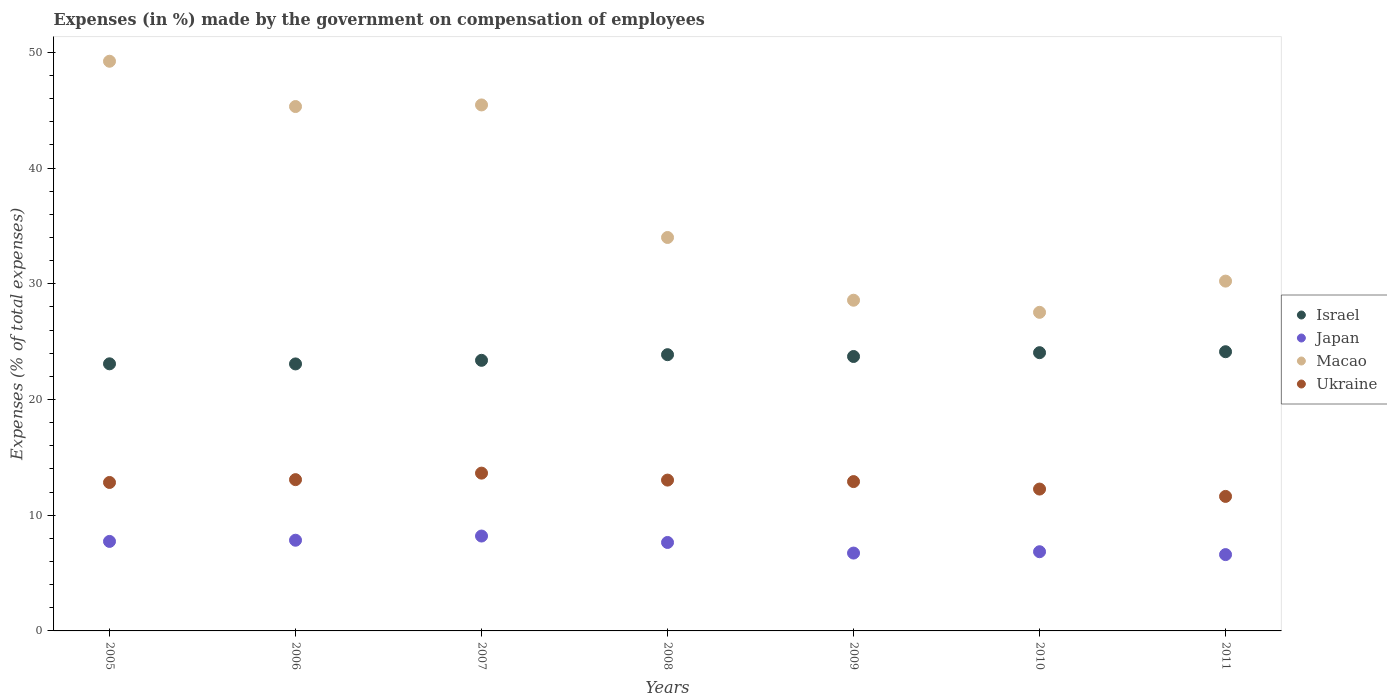How many different coloured dotlines are there?
Your answer should be very brief. 4. Is the number of dotlines equal to the number of legend labels?
Provide a short and direct response. Yes. What is the percentage of expenses made by the government on compensation of employees in Japan in 2006?
Make the answer very short. 7.84. Across all years, what is the maximum percentage of expenses made by the government on compensation of employees in Japan?
Provide a succinct answer. 8.2. Across all years, what is the minimum percentage of expenses made by the government on compensation of employees in Japan?
Your answer should be very brief. 6.6. In which year was the percentage of expenses made by the government on compensation of employees in Japan maximum?
Keep it short and to the point. 2007. In which year was the percentage of expenses made by the government on compensation of employees in Japan minimum?
Your answer should be compact. 2011. What is the total percentage of expenses made by the government on compensation of employees in Macao in the graph?
Offer a very short reply. 260.37. What is the difference between the percentage of expenses made by the government on compensation of employees in Macao in 2005 and that in 2009?
Make the answer very short. 20.65. What is the difference between the percentage of expenses made by the government on compensation of employees in Japan in 2011 and the percentage of expenses made by the government on compensation of employees in Israel in 2009?
Provide a short and direct response. -17.12. What is the average percentage of expenses made by the government on compensation of employees in Japan per year?
Your response must be concise. 7.37. In the year 2006, what is the difference between the percentage of expenses made by the government on compensation of employees in Japan and percentage of expenses made by the government on compensation of employees in Macao?
Give a very brief answer. -37.48. What is the ratio of the percentage of expenses made by the government on compensation of employees in Israel in 2006 to that in 2009?
Give a very brief answer. 0.97. What is the difference between the highest and the second highest percentage of expenses made by the government on compensation of employees in Ukraine?
Ensure brevity in your answer.  0.56. What is the difference between the highest and the lowest percentage of expenses made by the government on compensation of employees in Japan?
Provide a short and direct response. 1.6. In how many years, is the percentage of expenses made by the government on compensation of employees in Macao greater than the average percentage of expenses made by the government on compensation of employees in Macao taken over all years?
Provide a short and direct response. 3. Is the sum of the percentage of expenses made by the government on compensation of employees in Macao in 2005 and 2006 greater than the maximum percentage of expenses made by the government on compensation of employees in Japan across all years?
Ensure brevity in your answer.  Yes. Is it the case that in every year, the sum of the percentage of expenses made by the government on compensation of employees in Israel and percentage of expenses made by the government on compensation of employees in Japan  is greater than the sum of percentage of expenses made by the government on compensation of employees in Ukraine and percentage of expenses made by the government on compensation of employees in Macao?
Offer a terse response. No. Does the percentage of expenses made by the government on compensation of employees in Japan monotonically increase over the years?
Offer a terse response. No. Is the percentage of expenses made by the government on compensation of employees in Japan strictly greater than the percentage of expenses made by the government on compensation of employees in Ukraine over the years?
Offer a very short reply. No. Is the percentage of expenses made by the government on compensation of employees in Macao strictly less than the percentage of expenses made by the government on compensation of employees in Japan over the years?
Make the answer very short. No. How many years are there in the graph?
Your response must be concise. 7. What is the difference between two consecutive major ticks on the Y-axis?
Offer a very short reply. 10. Where does the legend appear in the graph?
Ensure brevity in your answer.  Center right. How are the legend labels stacked?
Your answer should be compact. Vertical. What is the title of the graph?
Ensure brevity in your answer.  Expenses (in %) made by the government on compensation of employees. Does "Sao Tome and Principe" appear as one of the legend labels in the graph?
Provide a succinct answer. No. What is the label or title of the X-axis?
Provide a short and direct response. Years. What is the label or title of the Y-axis?
Offer a terse response. Expenses (% of total expenses). What is the Expenses (% of total expenses) of Israel in 2005?
Give a very brief answer. 23.09. What is the Expenses (% of total expenses) of Japan in 2005?
Offer a very short reply. 7.74. What is the Expenses (% of total expenses) of Macao in 2005?
Your answer should be compact. 49.24. What is the Expenses (% of total expenses) of Ukraine in 2005?
Offer a terse response. 12.83. What is the Expenses (% of total expenses) in Israel in 2006?
Offer a very short reply. 23.08. What is the Expenses (% of total expenses) in Japan in 2006?
Your answer should be compact. 7.84. What is the Expenses (% of total expenses) of Macao in 2006?
Your answer should be compact. 45.32. What is the Expenses (% of total expenses) of Ukraine in 2006?
Offer a terse response. 13.07. What is the Expenses (% of total expenses) of Israel in 2007?
Your answer should be very brief. 23.39. What is the Expenses (% of total expenses) in Japan in 2007?
Provide a short and direct response. 8.2. What is the Expenses (% of total expenses) in Macao in 2007?
Provide a short and direct response. 45.46. What is the Expenses (% of total expenses) in Ukraine in 2007?
Make the answer very short. 13.64. What is the Expenses (% of total expenses) in Israel in 2008?
Give a very brief answer. 23.87. What is the Expenses (% of total expenses) in Japan in 2008?
Offer a very short reply. 7.65. What is the Expenses (% of total expenses) of Macao in 2008?
Your response must be concise. 34. What is the Expenses (% of total expenses) in Ukraine in 2008?
Provide a short and direct response. 13.04. What is the Expenses (% of total expenses) in Israel in 2009?
Ensure brevity in your answer.  23.72. What is the Expenses (% of total expenses) in Japan in 2009?
Your answer should be very brief. 6.73. What is the Expenses (% of total expenses) in Macao in 2009?
Offer a very short reply. 28.58. What is the Expenses (% of total expenses) of Ukraine in 2009?
Offer a terse response. 12.91. What is the Expenses (% of total expenses) in Israel in 2010?
Your answer should be compact. 24.05. What is the Expenses (% of total expenses) of Japan in 2010?
Make the answer very short. 6.85. What is the Expenses (% of total expenses) in Macao in 2010?
Your answer should be very brief. 27.54. What is the Expenses (% of total expenses) of Ukraine in 2010?
Offer a terse response. 12.26. What is the Expenses (% of total expenses) of Israel in 2011?
Make the answer very short. 24.13. What is the Expenses (% of total expenses) in Japan in 2011?
Give a very brief answer. 6.6. What is the Expenses (% of total expenses) of Macao in 2011?
Your response must be concise. 30.23. What is the Expenses (% of total expenses) of Ukraine in 2011?
Offer a terse response. 11.63. Across all years, what is the maximum Expenses (% of total expenses) in Israel?
Give a very brief answer. 24.13. Across all years, what is the maximum Expenses (% of total expenses) of Japan?
Keep it short and to the point. 8.2. Across all years, what is the maximum Expenses (% of total expenses) in Macao?
Keep it short and to the point. 49.24. Across all years, what is the maximum Expenses (% of total expenses) of Ukraine?
Ensure brevity in your answer.  13.64. Across all years, what is the minimum Expenses (% of total expenses) of Israel?
Ensure brevity in your answer.  23.08. Across all years, what is the minimum Expenses (% of total expenses) of Japan?
Your answer should be very brief. 6.6. Across all years, what is the minimum Expenses (% of total expenses) of Macao?
Your response must be concise. 27.54. Across all years, what is the minimum Expenses (% of total expenses) of Ukraine?
Provide a succinct answer. 11.63. What is the total Expenses (% of total expenses) of Israel in the graph?
Offer a terse response. 165.32. What is the total Expenses (% of total expenses) in Japan in the graph?
Keep it short and to the point. 51.59. What is the total Expenses (% of total expenses) of Macao in the graph?
Provide a succinct answer. 260.37. What is the total Expenses (% of total expenses) in Ukraine in the graph?
Your response must be concise. 89.37. What is the difference between the Expenses (% of total expenses) in Israel in 2005 and that in 2006?
Ensure brevity in your answer.  0.01. What is the difference between the Expenses (% of total expenses) of Japan in 2005 and that in 2006?
Your answer should be compact. -0.1. What is the difference between the Expenses (% of total expenses) in Macao in 2005 and that in 2006?
Give a very brief answer. 3.91. What is the difference between the Expenses (% of total expenses) in Ukraine in 2005 and that in 2006?
Provide a short and direct response. -0.24. What is the difference between the Expenses (% of total expenses) in Israel in 2005 and that in 2007?
Provide a short and direct response. -0.3. What is the difference between the Expenses (% of total expenses) of Japan in 2005 and that in 2007?
Provide a succinct answer. -0.46. What is the difference between the Expenses (% of total expenses) of Macao in 2005 and that in 2007?
Provide a short and direct response. 3.78. What is the difference between the Expenses (% of total expenses) of Ukraine in 2005 and that in 2007?
Ensure brevity in your answer.  -0.81. What is the difference between the Expenses (% of total expenses) in Israel in 2005 and that in 2008?
Your answer should be compact. -0.79. What is the difference between the Expenses (% of total expenses) in Japan in 2005 and that in 2008?
Offer a very short reply. 0.09. What is the difference between the Expenses (% of total expenses) of Macao in 2005 and that in 2008?
Provide a short and direct response. 15.23. What is the difference between the Expenses (% of total expenses) of Ukraine in 2005 and that in 2008?
Provide a succinct answer. -0.2. What is the difference between the Expenses (% of total expenses) of Israel in 2005 and that in 2009?
Offer a very short reply. -0.63. What is the difference between the Expenses (% of total expenses) of Japan in 2005 and that in 2009?
Keep it short and to the point. 1.01. What is the difference between the Expenses (% of total expenses) in Macao in 2005 and that in 2009?
Ensure brevity in your answer.  20.65. What is the difference between the Expenses (% of total expenses) of Ukraine in 2005 and that in 2009?
Provide a succinct answer. -0.08. What is the difference between the Expenses (% of total expenses) in Israel in 2005 and that in 2010?
Your response must be concise. -0.96. What is the difference between the Expenses (% of total expenses) in Japan in 2005 and that in 2010?
Provide a succinct answer. 0.89. What is the difference between the Expenses (% of total expenses) of Macao in 2005 and that in 2010?
Offer a terse response. 21.7. What is the difference between the Expenses (% of total expenses) in Ukraine in 2005 and that in 2010?
Ensure brevity in your answer.  0.57. What is the difference between the Expenses (% of total expenses) in Israel in 2005 and that in 2011?
Your response must be concise. -1.05. What is the difference between the Expenses (% of total expenses) in Japan in 2005 and that in 2011?
Offer a terse response. 1.14. What is the difference between the Expenses (% of total expenses) of Macao in 2005 and that in 2011?
Offer a very short reply. 19. What is the difference between the Expenses (% of total expenses) of Ukraine in 2005 and that in 2011?
Make the answer very short. 1.21. What is the difference between the Expenses (% of total expenses) of Israel in 2006 and that in 2007?
Provide a short and direct response. -0.31. What is the difference between the Expenses (% of total expenses) in Japan in 2006 and that in 2007?
Provide a succinct answer. -0.36. What is the difference between the Expenses (% of total expenses) in Macao in 2006 and that in 2007?
Provide a short and direct response. -0.14. What is the difference between the Expenses (% of total expenses) in Ukraine in 2006 and that in 2007?
Offer a very short reply. -0.56. What is the difference between the Expenses (% of total expenses) of Israel in 2006 and that in 2008?
Your response must be concise. -0.8. What is the difference between the Expenses (% of total expenses) in Japan in 2006 and that in 2008?
Offer a very short reply. 0.19. What is the difference between the Expenses (% of total expenses) of Macao in 2006 and that in 2008?
Offer a terse response. 11.32. What is the difference between the Expenses (% of total expenses) in Ukraine in 2006 and that in 2008?
Your response must be concise. 0.04. What is the difference between the Expenses (% of total expenses) in Israel in 2006 and that in 2009?
Your response must be concise. -0.64. What is the difference between the Expenses (% of total expenses) in Japan in 2006 and that in 2009?
Offer a very short reply. 1.11. What is the difference between the Expenses (% of total expenses) of Macao in 2006 and that in 2009?
Keep it short and to the point. 16.74. What is the difference between the Expenses (% of total expenses) of Ukraine in 2006 and that in 2009?
Keep it short and to the point. 0.17. What is the difference between the Expenses (% of total expenses) of Israel in 2006 and that in 2010?
Offer a very short reply. -0.97. What is the difference between the Expenses (% of total expenses) in Japan in 2006 and that in 2010?
Your response must be concise. 0.99. What is the difference between the Expenses (% of total expenses) in Macao in 2006 and that in 2010?
Provide a succinct answer. 17.79. What is the difference between the Expenses (% of total expenses) in Ukraine in 2006 and that in 2010?
Provide a succinct answer. 0.81. What is the difference between the Expenses (% of total expenses) of Israel in 2006 and that in 2011?
Make the answer very short. -1.05. What is the difference between the Expenses (% of total expenses) of Japan in 2006 and that in 2011?
Make the answer very short. 1.24. What is the difference between the Expenses (% of total expenses) in Macao in 2006 and that in 2011?
Ensure brevity in your answer.  15.09. What is the difference between the Expenses (% of total expenses) of Ukraine in 2006 and that in 2011?
Offer a very short reply. 1.45. What is the difference between the Expenses (% of total expenses) in Israel in 2007 and that in 2008?
Offer a very short reply. -0.49. What is the difference between the Expenses (% of total expenses) in Japan in 2007 and that in 2008?
Give a very brief answer. 0.56. What is the difference between the Expenses (% of total expenses) in Macao in 2007 and that in 2008?
Provide a succinct answer. 11.46. What is the difference between the Expenses (% of total expenses) in Ukraine in 2007 and that in 2008?
Give a very brief answer. 0.6. What is the difference between the Expenses (% of total expenses) of Israel in 2007 and that in 2009?
Ensure brevity in your answer.  -0.33. What is the difference between the Expenses (% of total expenses) of Japan in 2007 and that in 2009?
Make the answer very short. 1.47. What is the difference between the Expenses (% of total expenses) in Macao in 2007 and that in 2009?
Provide a short and direct response. 16.88. What is the difference between the Expenses (% of total expenses) of Ukraine in 2007 and that in 2009?
Make the answer very short. 0.73. What is the difference between the Expenses (% of total expenses) in Israel in 2007 and that in 2010?
Offer a very short reply. -0.66. What is the difference between the Expenses (% of total expenses) of Japan in 2007 and that in 2010?
Give a very brief answer. 1.36. What is the difference between the Expenses (% of total expenses) of Macao in 2007 and that in 2010?
Ensure brevity in your answer.  17.93. What is the difference between the Expenses (% of total expenses) in Ukraine in 2007 and that in 2010?
Make the answer very short. 1.38. What is the difference between the Expenses (% of total expenses) in Israel in 2007 and that in 2011?
Provide a succinct answer. -0.74. What is the difference between the Expenses (% of total expenses) in Japan in 2007 and that in 2011?
Keep it short and to the point. 1.6. What is the difference between the Expenses (% of total expenses) in Macao in 2007 and that in 2011?
Keep it short and to the point. 15.23. What is the difference between the Expenses (% of total expenses) in Ukraine in 2007 and that in 2011?
Ensure brevity in your answer.  2.01. What is the difference between the Expenses (% of total expenses) of Israel in 2008 and that in 2009?
Keep it short and to the point. 0.16. What is the difference between the Expenses (% of total expenses) of Japan in 2008 and that in 2009?
Keep it short and to the point. 0.92. What is the difference between the Expenses (% of total expenses) of Macao in 2008 and that in 2009?
Offer a terse response. 5.42. What is the difference between the Expenses (% of total expenses) in Ukraine in 2008 and that in 2009?
Your answer should be compact. 0.13. What is the difference between the Expenses (% of total expenses) of Israel in 2008 and that in 2010?
Make the answer very short. -0.17. What is the difference between the Expenses (% of total expenses) in Japan in 2008 and that in 2010?
Offer a very short reply. 0.8. What is the difference between the Expenses (% of total expenses) of Macao in 2008 and that in 2010?
Your response must be concise. 6.47. What is the difference between the Expenses (% of total expenses) in Ukraine in 2008 and that in 2010?
Ensure brevity in your answer.  0.78. What is the difference between the Expenses (% of total expenses) of Israel in 2008 and that in 2011?
Give a very brief answer. -0.26. What is the difference between the Expenses (% of total expenses) of Japan in 2008 and that in 2011?
Make the answer very short. 1.05. What is the difference between the Expenses (% of total expenses) of Macao in 2008 and that in 2011?
Provide a succinct answer. 3.77. What is the difference between the Expenses (% of total expenses) in Ukraine in 2008 and that in 2011?
Offer a very short reply. 1.41. What is the difference between the Expenses (% of total expenses) in Israel in 2009 and that in 2010?
Offer a very short reply. -0.33. What is the difference between the Expenses (% of total expenses) of Japan in 2009 and that in 2010?
Offer a terse response. -0.12. What is the difference between the Expenses (% of total expenses) of Macao in 2009 and that in 2010?
Ensure brevity in your answer.  1.05. What is the difference between the Expenses (% of total expenses) in Ukraine in 2009 and that in 2010?
Offer a terse response. 0.65. What is the difference between the Expenses (% of total expenses) in Israel in 2009 and that in 2011?
Give a very brief answer. -0.41. What is the difference between the Expenses (% of total expenses) of Japan in 2009 and that in 2011?
Your answer should be compact. 0.13. What is the difference between the Expenses (% of total expenses) in Macao in 2009 and that in 2011?
Provide a short and direct response. -1.65. What is the difference between the Expenses (% of total expenses) in Ukraine in 2009 and that in 2011?
Provide a short and direct response. 1.28. What is the difference between the Expenses (% of total expenses) of Israel in 2010 and that in 2011?
Ensure brevity in your answer.  -0.08. What is the difference between the Expenses (% of total expenses) in Japan in 2010 and that in 2011?
Offer a terse response. 0.25. What is the difference between the Expenses (% of total expenses) of Macao in 2010 and that in 2011?
Provide a succinct answer. -2.7. What is the difference between the Expenses (% of total expenses) of Ukraine in 2010 and that in 2011?
Offer a terse response. 0.63. What is the difference between the Expenses (% of total expenses) of Israel in 2005 and the Expenses (% of total expenses) of Japan in 2006?
Make the answer very short. 15.25. What is the difference between the Expenses (% of total expenses) of Israel in 2005 and the Expenses (% of total expenses) of Macao in 2006?
Your answer should be compact. -22.24. What is the difference between the Expenses (% of total expenses) in Israel in 2005 and the Expenses (% of total expenses) in Ukraine in 2006?
Provide a succinct answer. 10.01. What is the difference between the Expenses (% of total expenses) of Japan in 2005 and the Expenses (% of total expenses) of Macao in 2006?
Offer a very short reply. -37.59. What is the difference between the Expenses (% of total expenses) of Japan in 2005 and the Expenses (% of total expenses) of Ukraine in 2006?
Make the answer very short. -5.34. What is the difference between the Expenses (% of total expenses) of Macao in 2005 and the Expenses (% of total expenses) of Ukraine in 2006?
Give a very brief answer. 36.16. What is the difference between the Expenses (% of total expenses) in Israel in 2005 and the Expenses (% of total expenses) in Japan in 2007?
Provide a succinct answer. 14.89. What is the difference between the Expenses (% of total expenses) in Israel in 2005 and the Expenses (% of total expenses) in Macao in 2007?
Provide a succinct answer. -22.38. What is the difference between the Expenses (% of total expenses) of Israel in 2005 and the Expenses (% of total expenses) of Ukraine in 2007?
Give a very brief answer. 9.45. What is the difference between the Expenses (% of total expenses) in Japan in 2005 and the Expenses (% of total expenses) in Macao in 2007?
Give a very brief answer. -37.72. What is the difference between the Expenses (% of total expenses) of Japan in 2005 and the Expenses (% of total expenses) of Ukraine in 2007?
Your response must be concise. -5.9. What is the difference between the Expenses (% of total expenses) in Macao in 2005 and the Expenses (% of total expenses) in Ukraine in 2007?
Ensure brevity in your answer.  35.6. What is the difference between the Expenses (% of total expenses) in Israel in 2005 and the Expenses (% of total expenses) in Japan in 2008?
Your answer should be compact. 15.44. What is the difference between the Expenses (% of total expenses) of Israel in 2005 and the Expenses (% of total expenses) of Macao in 2008?
Your answer should be compact. -10.92. What is the difference between the Expenses (% of total expenses) of Israel in 2005 and the Expenses (% of total expenses) of Ukraine in 2008?
Ensure brevity in your answer.  10.05. What is the difference between the Expenses (% of total expenses) in Japan in 2005 and the Expenses (% of total expenses) in Macao in 2008?
Provide a succinct answer. -26.27. What is the difference between the Expenses (% of total expenses) of Japan in 2005 and the Expenses (% of total expenses) of Ukraine in 2008?
Ensure brevity in your answer.  -5.3. What is the difference between the Expenses (% of total expenses) in Macao in 2005 and the Expenses (% of total expenses) in Ukraine in 2008?
Keep it short and to the point. 36.2. What is the difference between the Expenses (% of total expenses) of Israel in 2005 and the Expenses (% of total expenses) of Japan in 2009?
Provide a short and direct response. 16.36. What is the difference between the Expenses (% of total expenses) of Israel in 2005 and the Expenses (% of total expenses) of Macao in 2009?
Your answer should be very brief. -5.5. What is the difference between the Expenses (% of total expenses) of Israel in 2005 and the Expenses (% of total expenses) of Ukraine in 2009?
Your answer should be compact. 10.18. What is the difference between the Expenses (% of total expenses) in Japan in 2005 and the Expenses (% of total expenses) in Macao in 2009?
Provide a short and direct response. -20.85. What is the difference between the Expenses (% of total expenses) in Japan in 2005 and the Expenses (% of total expenses) in Ukraine in 2009?
Your answer should be very brief. -5.17. What is the difference between the Expenses (% of total expenses) in Macao in 2005 and the Expenses (% of total expenses) in Ukraine in 2009?
Offer a very short reply. 36.33. What is the difference between the Expenses (% of total expenses) in Israel in 2005 and the Expenses (% of total expenses) in Japan in 2010?
Your answer should be very brief. 16.24. What is the difference between the Expenses (% of total expenses) of Israel in 2005 and the Expenses (% of total expenses) of Macao in 2010?
Provide a succinct answer. -4.45. What is the difference between the Expenses (% of total expenses) of Israel in 2005 and the Expenses (% of total expenses) of Ukraine in 2010?
Make the answer very short. 10.82. What is the difference between the Expenses (% of total expenses) in Japan in 2005 and the Expenses (% of total expenses) in Macao in 2010?
Keep it short and to the point. -19.8. What is the difference between the Expenses (% of total expenses) in Japan in 2005 and the Expenses (% of total expenses) in Ukraine in 2010?
Provide a succinct answer. -4.52. What is the difference between the Expenses (% of total expenses) in Macao in 2005 and the Expenses (% of total expenses) in Ukraine in 2010?
Provide a succinct answer. 36.98. What is the difference between the Expenses (% of total expenses) of Israel in 2005 and the Expenses (% of total expenses) of Japan in 2011?
Offer a terse response. 16.49. What is the difference between the Expenses (% of total expenses) of Israel in 2005 and the Expenses (% of total expenses) of Macao in 2011?
Keep it short and to the point. -7.15. What is the difference between the Expenses (% of total expenses) in Israel in 2005 and the Expenses (% of total expenses) in Ukraine in 2011?
Your answer should be very brief. 11.46. What is the difference between the Expenses (% of total expenses) in Japan in 2005 and the Expenses (% of total expenses) in Macao in 2011?
Give a very brief answer. -22.5. What is the difference between the Expenses (% of total expenses) in Japan in 2005 and the Expenses (% of total expenses) in Ukraine in 2011?
Your answer should be very brief. -3.89. What is the difference between the Expenses (% of total expenses) in Macao in 2005 and the Expenses (% of total expenses) in Ukraine in 2011?
Your response must be concise. 37.61. What is the difference between the Expenses (% of total expenses) in Israel in 2006 and the Expenses (% of total expenses) in Japan in 2007?
Your answer should be compact. 14.88. What is the difference between the Expenses (% of total expenses) in Israel in 2006 and the Expenses (% of total expenses) in Macao in 2007?
Your response must be concise. -22.38. What is the difference between the Expenses (% of total expenses) of Israel in 2006 and the Expenses (% of total expenses) of Ukraine in 2007?
Offer a very short reply. 9.44. What is the difference between the Expenses (% of total expenses) of Japan in 2006 and the Expenses (% of total expenses) of Macao in 2007?
Offer a very short reply. -37.62. What is the difference between the Expenses (% of total expenses) of Japan in 2006 and the Expenses (% of total expenses) of Ukraine in 2007?
Ensure brevity in your answer.  -5.8. What is the difference between the Expenses (% of total expenses) of Macao in 2006 and the Expenses (% of total expenses) of Ukraine in 2007?
Make the answer very short. 31.68. What is the difference between the Expenses (% of total expenses) of Israel in 2006 and the Expenses (% of total expenses) of Japan in 2008?
Offer a very short reply. 15.43. What is the difference between the Expenses (% of total expenses) of Israel in 2006 and the Expenses (% of total expenses) of Macao in 2008?
Provide a succinct answer. -10.93. What is the difference between the Expenses (% of total expenses) of Israel in 2006 and the Expenses (% of total expenses) of Ukraine in 2008?
Your response must be concise. 10.04. What is the difference between the Expenses (% of total expenses) in Japan in 2006 and the Expenses (% of total expenses) in Macao in 2008?
Make the answer very short. -26.17. What is the difference between the Expenses (% of total expenses) of Japan in 2006 and the Expenses (% of total expenses) of Ukraine in 2008?
Your answer should be compact. -5.2. What is the difference between the Expenses (% of total expenses) of Macao in 2006 and the Expenses (% of total expenses) of Ukraine in 2008?
Your answer should be very brief. 32.29. What is the difference between the Expenses (% of total expenses) of Israel in 2006 and the Expenses (% of total expenses) of Japan in 2009?
Your response must be concise. 16.35. What is the difference between the Expenses (% of total expenses) of Israel in 2006 and the Expenses (% of total expenses) of Macao in 2009?
Give a very brief answer. -5.51. What is the difference between the Expenses (% of total expenses) in Israel in 2006 and the Expenses (% of total expenses) in Ukraine in 2009?
Offer a terse response. 10.17. What is the difference between the Expenses (% of total expenses) of Japan in 2006 and the Expenses (% of total expenses) of Macao in 2009?
Provide a succinct answer. -20.74. What is the difference between the Expenses (% of total expenses) of Japan in 2006 and the Expenses (% of total expenses) of Ukraine in 2009?
Ensure brevity in your answer.  -5.07. What is the difference between the Expenses (% of total expenses) of Macao in 2006 and the Expenses (% of total expenses) of Ukraine in 2009?
Offer a very short reply. 32.41. What is the difference between the Expenses (% of total expenses) in Israel in 2006 and the Expenses (% of total expenses) in Japan in 2010?
Your answer should be compact. 16.23. What is the difference between the Expenses (% of total expenses) in Israel in 2006 and the Expenses (% of total expenses) in Macao in 2010?
Your answer should be compact. -4.46. What is the difference between the Expenses (% of total expenses) of Israel in 2006 and the Expenses (% of total expenses) of Ukraine in 2010?
Provide a succinct answer. 10.82. What is the difference between the Expenses (% of total expenses) of Japan in 2006 and the Expenses (% of total expenses) of Macao in 2010?
Provide a short and direct response. -19.7. What is the difference between the Expenses (% of total expenses) in Japan in 2006 and the Expenses (% of total expenses) in Ukraine in 2010?
Ensure brevity in your answer.  -4.42. What is the difference between the Expenses (% of total expenses) of Macao in 2006 and the Expenses (% of total expenses) of Ukraine in 2010?
Provide a succinct answer. 33.06. What is the difference between the Expenses (% of total expenses) in Israel in 2006 and the Expenses (% of total expenses) in Japan in 2011?
Keep it short and to the point. 16.48. What is the difference between the Expenses (% of total expenses) in Israel in 2006 and the Expenses (% of total expenses) in Macao in 2011?
Offer a terse response. -7.16. What is the difference between the Expenses (% of total expenses) in Israel in 2006 and the Expenses (% of total expenses) in Ukraine in 2011?
Offer a terse response. 11.45. What is the difference between the Expenses (% of total expenses) in Japan in 2006 and the Expenses (% of total expenses) in Macao in 2011?
Give a very brief answer. -22.39. What is the difference between the Expenses (% of total expenses) of Japan in 2006 and the Expenses (% of total expenses) of Ukraine in 2011?
Make the answer very short. -3.79. What is the difference between the Expenses (% of total expenses) in Macao in 2006 and the Expenses (% of total expenses) in Ukraine in 2011?
Give a very brief answer. 33.7. What is the difference between the Expenses (% of total expenses) of Israel in 2007 and the Expenses (% of total expenses) of Japan in 2008?
Your response must be concise. 15.74. What is the difference between the Expenses (% of total expenses) of Israel in 2007 and the Expenses (% of total expenses) of Macao in 2008?
Offer a very short reply. -10.62. What is the difference between the Expenses (% of total expenses) in Israel in 2007 and the Expenses (% of total expenses) in Ukraine in 2008?
Provide a succinct answer. 10.35. What is the difference between the Expenses (% of total expenses) in Japan in 2007 and the Expenses (% of total expenses) in Macao in 2008?
Provide a short and direct response. -25.8. What is the difference between the Expenses (% of total expenses) in Japan in 2007 and the Expenses (% of total expenses) in Ukraine in 2008?
Give a very brief answer. -4.84. What is the difference between the Expenses (% of total expenses) in Macao in 2007 and the Expenses (% of total expenses) in Ukraine in 2008?
Your answer should be very brief. 32.42. What is the difference between the Expenses (% of total expenses) in Israel in 2007 and the Expenses (% of total expenses) in Japan in 2009?
Provide a succinct answer. 16.66. What is the difference between the Expenses (% of total expenses) in Israel in 2007 and the Expenses (% of total expenses) in Macao in 2009?
Give a very brief answer. -5.19. What is the difference between the Expenses (% of total expenses) of Israel in 2007 and the Expenses (% of total expenses) of Ukraine in 2009?
Your answer should be very brief. 10.48. What is the difference between the Expenses (% of total expenses) in Japan in 2007 and the Expenses (% of total expenses) in Macao in 2009?
Keep it short and to the point. -20.38. What is the difference between the Expenses (% of total expenses) of Japan in 2007 and the Expenses (% of total expenses) of Ukraine in 2009?
Give a very brief answer. -4.71. What is the difference between the Expenses (% of total expenses) of Macao in 2007 and the Expenses (% of total expenses) of Ukraine in 2009?
Keep it short and to the point. 32.55. What is the difference between the Expenses (% of total expenses) in Israel in 2007 and the Expenses (% of total expenses) in Japan in 2010?
Make the answer very short. 16.54. What is the difference between the Expenses (% of total expenses) in Israel in 2007 and the Expenses (% of total expenses) in Macao in 2010?
Offer a very short reply. -4.15. What is the difference between the Expenses (% of total expenses) in Israel in 2007 and the Expenses (% of total expenses) in Ukraine in 2010?
Your response must be concise. 11.13. What is the difference between the Expenses (% of total expenses) of Japan in 2007 and the Expenses (% of total expenses) of Macao in 2010?
Your answer should be compact. -19.34. What is the difference between the Expenses (% of total expenses) of Japan in 2007 and the Expenses (% of total expenses) of Ukraine in 2010?
Provide a succinct answer. -4.06. What is the difference between the Expenses (% of total expenses) of Macao in 2007 and the Expenses (% of total expenses) of Ukraine in 2010?
Provide a short and direct response. 33.2. What is the difference between the Expenses (% of total expenses) of Israel in 2007 and the Expenses (% of total expenses) of Japan in 2011?
Your response must be concise. 16.79. What is the difference between the Expenses (% of total expenses) in Israel in 2007 and the Expenses (% of total expenses) in Macao in 2011?
Make the answer very short. -6.85. What is the difference between the Expenses (% of total expenses) of Israel in 2007 and the Expenses (% of total expenses) of Ukraine in 2011?
Provide a succinct answer. 11.76. What is the difference between the Expenses (% of total expenses) of Japan in 2007 and the Expenses (% of total expenses) of Macao in 2011?
Make the answer very short. -22.03. What is the difference between the Expenses (% of total expenses) of Japan in 2007 and the Expenses (% of total expenses) of Ukraine in 2011?
Make the answer very short. -3.43. What is the difference between the Expenses (% of total expenses) in Macao in 2007 and the Expenses (% of total expenses) in Ukraine in 2011?
Your response must be concise. 33.83. What is the difference between the Expenses (% of total expenses) of Israel in 2008 and the Expenses (% of total expenses) of Japan in 2009?
Give a very brief answer. 17.15. What is the difference between the Expenses (% of total expenses) of Israel in 2008 and the Expenses (% of total expenses) of Macao in 2009?
Your answer should be compact. -4.71. What is the difference between the Expenses (% of total expenses) in Israel in 2008 and the Expenses (% of total expenses) in Ukraine in 2009?
Your response must be concise. 10.97. What is the difference between the Expenses (% of total expenses) in Japan in 2008 and the Expenses (% of total expenses) in Macao in 2009?
Ensure brevity in your answer.  -20.94. What is the difference between the Expenses (% of total expenses) of Japan in 2008 and the Expenses (% of total expenses) of Ukraine in 2009?
Offer a very short reply. -5.26. What is the difference between the Expenses (% of total expenses) in Macao in 2008 and the Expenses (% of total expenses) in Ukraine in 2009?
Provide a short and direct response. 21.1. What is the difference between the Expenses (% of total expenses) of Israel in 2008 and the Expenses (% of total expenses) of Japan in 2010?
Keep it short and to the point. 17.03. What is the difference between the Expenses (% of total expenses) of Israel in 2008 and the Expenses (% of total expenses) of Macao in 2010?
Ensure brevity in your answer.  -3.66. What is the difference between the Expenses (% of total expenses) in Israel in 2008 and the Expenses (% of total expenses) in Ukraine in 2010?
Ensure brevity in your answer.  11.61. What is the difference between the Expenses (% of total expenses) in Japan in 2008 and the Expenses (% of total expenses) in Macao in 2010?
Your answer should be compact. -19.89. What is the difference between the Expenses (% of total expenses) of Japan in 2008 and the Expenses (% of total expenses) of Ukraine in 2010?
Provide a short and direct response. -4.62. What is the difference between the Expenses (% of total expenses) of Macao in 2008 and the Expenses (% of total expenses) of Ukraine in 2010?
Offer a very short reply. 21.74. What is the difference between the Expenses (% of total expenses) of Israel in 2008 and the Expenses (% of total expenses) of Japan in 2011?
Keep it short and to the point. 17.28. What is the difference between the Expenses (% of total expenses) in Israel in 2008 and the Expenses (% of total expenses) in Macao in 2011?
Offer a very short reply. -6.36. What is the difference between the Expenses (% of total expenses) of Israel in 2008 and the Expenses (% of total expenses) of Ukraine in 2011?
Your answer should be very brief. 12.25. What is the difference between the Expenses (% of total expenses) in Japan in 2008 and the Expenses (% of total expenses) in Macao in 2011?
Give a very brief answer. -22.59. What is the difference between the Expenses (% of total expenses) of Japan in 2008 and the Expenses (% of total expenses) of Ukraine in 2011?
Offer a terse response. -3.98. What is the difference between the Expenses (% of total expenses) of Macao in 2008 and the Expenses (% of total expenses) of Ukraine in 2011?
Provide a short and direct response. 22.38. What is the difference between the Expenses (% of total expenses) in Israel in 2009 and the Expenses (% of total expenses) in Japan in 2010?
Offer a very short reply. 16.87. What is the difference between the Expenses (% of total expenses) in Israel in 2009 and the Expenses (% of total expenses) in Macao in 2010?
Offer a terse response. -3.82. What is the difference between the Expenses (% of total expenses) of Israel in 2009 and the Expenses (% of total expenses) of Ukraine in 2010?
Your answer should be compact. 11.46. What is the difference between the Expenses (% of total expenses) of Japan in 2009 and the Expenses (% of total expenses) of Macao in 2010?
Provide a short and direct response. -20.81. What is the difference between the Expenses (% of total expenses) of Japan in 2009 and the Expenses (% of total expenses) of Ukraine in 2010?
Offer a terse response. -5.53. What is the difference between the Expenses (% of total expenses) of Macao in 2009 and the Expenses (% of total expenses) of Ukraine in 2010?
Make the answer very short. 16.32. What is the difference between the Expenses (% of total expenses) of Israel in 2009 and the Expenses (% of total expenses) of Japan in 2011?
Offer a very short reply. 17.12. What is the difference between the Expenses (% of total expenses) in Israel in 2009 and the Expenses (% of total expenses) in Macao in 2011?
Provide a succinct answer. -6.51. What is the difference between the Expenses (% of total expenses) of Israel in 2009 and the Expenses (% of total expenses) of Ukraine in 2011?
Your response must be concise. 12.09. What is the difference between the Expenses (% of total expenses) of Japan in 2009 and the Expenses (% of total expenses) of Macao in 2011?
Offer a terse response. -23.51. What is the difference between the Expenses (% of total expenses) in Japan in 2009 and the Expenses (% of total expenses) in Ukraine in 2011?
Ensure brevity in your answer.  -4.9. What is the difference between the Expenses (% of total expenses) of Macao in 2009 and the Expenses (% of total expenses) of Ukraine in 2011?
Give a very brief answer. 16.96. What is the difference between the Expenses (% of total expenses) of Israel in 2010 and the Expenses (% of total expenses) of Japan in 2011?
Your answer should be very brief. 17.45. What is the difference between the Expenses (% of total expenses) of Israel in 2010 and the Expenses (% of total expenses) of Macao in 2011?
Offer a very short reply. -6.18. What is the difference between the Expenses (% of total expenses) in Israel in 2010 and the Expenses (% of total expenses) in Ukraine in 2011?
Offer a terse response. 12.42. What is the difference between the Expenses (% of total expenses) in Japan in 2010 and the Expenses (% of total expenses) in Macao in 2011?
Provide a short and direct response. -23.39. What is the difference between the Expenses (% of total expenses) in Japan in 2010 and the Expenses (% of total expenses) in Ukraine in 2011?
Provide a short and direct response. -4.78. What is the difference between the Expenses (% of total expenses) of Macao in 2010 and the Expenses (% of total expenses) of Ukraine in 2011?
Provide a short and direct response. 15.91. What is the average Expenses (% of total expenses) of Israel per year?
Your answer should be compact. 23.62. What is the average Expenses (% of total expenses) of Japan per year?
Keep it short and to the point. 7.37. What is the average Expenses (% of total expenses) of Macao per year?
Ensure brevity in your answer.  37.2. What is the average Expenses (% of total expenses) in Ukraine per year?
Give a very brief answer. 12.77. In the year 2005, what is the difference between the Expenses (% of total expenses) in Israel and Expenses (% of total expenses) in Japan?
Your response must be concise. 15.35. In the year 2005, what is the difference between the Expenses (% of total expenses) in Israel and Expenses (% of total expenses) in Macao?
Your response must be concise. -26.15. In the year 2005, what is the difference between the Expenses (% of total expenses) of Israel and Expenses (% of total expenses) of Ukraine?
Ensure brevity in your answer.  10.25. In the year 2005, what is the difference between the Expenses (% of total expenses) in Japan and Expenses (% of total expenses) in Macao?
Your answer should be very brief. -41.5. In the year 2005, what is the difference between the Expenses (% of total expenses) of Japan and Expenses (% of total expenses) of Ukraine?
Provide a succinct answer. -5.09. In the year 2005, what is the difference between the Expenses (% of total expenses) of Macao and Expenses (% of total expenses) of Ukraine?
Ensure brevity in your answer.  36.41. In the year 2006, what is the difference between the Expenses (% of total expenses) of Israel and Expenses (% of total expenses) of Japan?
Provide a short and direct response. 15.24. In the year 2006, what is the difference between the Expenses (% of total expenses) in Israel and Expenses (% of total expenses) in Macao?
Keep it short and to the point. -22.25. In the year 2006, what is the difference between the Expenses (% of total expenses) of Israel and Expenses (% of total expenses) of Ukraine?
Offer a very short reply. 10. In the year 2006, what is the difference between the Expenses (% of total expenses) in Japan and Expenses (% of total expenses) in Macao?
Offer a terse response. -37.48. In the year 2006, what is the difference between the Expenses (% of total expenses) of Japan and Expenses (% of total expenses) of Ukraine?
Your answer should be very brief. -5.24. In the year 2006, what is the difference between the Expenses (% of total expenses) in Macao and Expenses (% of total expenses) in Ukraine?
Ensure brevity in your answer.  32.25. In the year 2007, what is the difference between the Expenses (% of total expenses) in Israel and Expenses (% of total expenses) in Japan?
Provide a succinct answer. 15.19. In the year 2007, what is the difference between the Expenses (% of total expenses) of Israel and Expenses (% of total expenses) of Macao?
Provide a succinct answer. -22.07. In the year 2007, what is the difference between the Expenses (% of total expenses) of Israel and Expenses (% of total expenses) of Ukraine?
Provide a succinct answer. 9.75. In the year 2007, what is the difference between the Expenses (% of total expenses) of Japan and Expenses (% of total expenses) of Macao?
Your answer should be very brief. -37.26. In the year 2007, what is the difference between the Expenses (% of total expenses) in Japan and Expenses (% of total expenses) in Ukraine?
Keep it short and to the point. -5.44. In the year 2007, what is the difference between the Expenses (% of total expenses) in Macao and Expenses (% of total expenses) in Ukraine?
Your answer should be very brief. 31.82. In the year 2008, what is the difference between the Expenses (% of total expenses) in Israel and Expenses (% of total expenses) in Japan?
Keep it short and to the point. 16.23. In the year 2008, what is the difference between the Expenses (% of total expenses) in Israel and Expenses (% of total expenses) in Macao?
Offer a terse response. -10.13. In the year 2008, what is the difference between the Expenses (% of total expenses) in Israel and Expenses (% of total expenses) in Ukraine?
Your answer should be compact. 10.84. In the year 2008, what is the difference between the Expenses (% of total expenses) in Japan and Expenses (% of total expenses) in Macao?
Offer a very short reply. -26.36. In the year 2008, what is the difference between the Expenses (% of total expenses) in Japan and Expenses (% of total expenses) in Ukraine?
Keep it short and to the point. -5.39. In the year 2008, what is the difference between the Expenses (% of total expenses) of Macao and Expenses (% of total expenses) of Ukraine?
Your answer should be compact. 20.97. In the year 2009, what is the difference between the Expenses (% of total expenses) in Israel and Expenses (% of total expenses) in Japan?
Keep it short and to the point. 16.99. In the year 2009, what is the difference between the Expenses (% of total expenses) in Israel and Expenses (% of total expenses) in Macao?
Your response must be concise. -4.86. In the year 2009, what is the difference between the Expenses (% of total expenses) in Israel and Expenses (% of total expenses) in Ukraine?
Make the answer very short. 10.81. In the year 2009, what is the difference between the Expenses (% of total expenses) in Japan and Expenses (% of total expenses) in Macao?
Offer a very short reply. -21.85. In the year 2009, what is the difference between the Expenses (% of total expenses) of Japan and Expenses (% of total expenses) of Ukraine?
Make the answer very short. -6.18. In the year 2009, what is the difference between the Expenses (% of total expenses) in Macao and Expenses (% of total expenses) in Ukraine?
Provide a succinct answer. 15.68. In the year 2010, what is the difference between the Expenses (% of total expenses) of Israel and Expenses (% of total expenses) of Japan?
Make the answer very short. 17.2. In the year 2010, what is the difference between the Expenses (% of total expenses) in Israel and Expenses (% of total expenses) in Macao?
Give a very brief answer. -3.49. In the year 2010, what is the difference between the Expenses (% of total expenses) of Israel and Expenses (% of total expenses) of Ukraine?
Your response must be concise. 11.79. In the year 2010, what is the difference between the Expenses (% of total expenses) in Japan and Expenses (% of total expenses) in Macao?
Make the answer very short. -20.69. In the year 2010, what is the difference between the Expenses (% of total expenses) of Japan and Expenses (% of total expenses) of Ukraine?
Your answer should be very brief. -5.42. In the year 2010, what is the difference between the Expenses (% of total expenses) of Macao and Expenses (% of total expenses) of Ukraine?
Your answer should be very brief. 15.27. In the year 2011, what is the difference between the Expenses (% of total expenses) of Israel and Expenses (% of total expenses) of Japan?
Provide a succinct answer. 17.53. In the year 2011, what is the difference between the Expenses (% of total expenses) of Israel and Expenses (% of total expenses) of Macao?
Offer a terse response. -6.1. In the year 2011, what is the difference between the Expenses (% of total expenses) of Israel and Expenses (% of total expenses) of Ukraine?
Your answer should be compact. 12.51. In the year 2011, what is the difference between the Expenses (% of total expenses) in Japan and Expenses (% of total expenses) in Macao?
Provide a short and direct response. -23.64. In the year 2011, what is the difference between the Expenses (% of total expenses) in Japan and Expenses (% of total expenses) in Ukraine?
Make the answer very short. -5.03. In the year 2011, what is the difference between the Expenses (% of total expenses) of Macao and Expenses (% of total expenses) of Ukraine?
Offer a very short reply. 18.61. What is the ratio of the Expenses (% of total expenses) in Israel in 2005 to that in 2006?
Provide a short and direct response. 1. What is the ratio of the Expenses (% of total expenses) in Japan in 2005 to that in 2006?
Provide a succinct answer. 0.99. What is the ratio of the Expenses (% of total expenses) of Macao in 2005 to that in 2006?
Your answer should be very brief. 1.09. What is the ratio of the Expenses (% of total expenses) of Ukraine in 2005 to that in 2006?
Your answer should be very brief. 0.98. What is the ratio of the Expenses (% of total expenses) of Israel in 2005 to that in 2007?
Provide a succinct answer. 0.99. What is the ratio of the Expenses (% of total expenses) of Japan in 2005 to that in 2007?
Provide a short and direct response. 0.94. What is the ratio of the Expenses (% of total expenses) of Macao in 2005 to that in 2007?
Provide a short and direct response. 1.08. What is the ratio of the Expenses (% of total expenses) in Ukraine in 2005 to that in 2007?
Provide a short and direct response. 0.94. What is the ratio of the Expenses (% of total expenses) in Israel in 2005 to that in 2008?
Your response must be concise. 0.97. What is the ratio of the Expenses (% of total expenses) of Japan in 2005 to that in 2008?
Provide a succinct answer. 1.01. What is the ratio of the Expenses (% of total expenses) in Macao in 2005 to that in 2008?
Offer a terse response. 1.45. What is the ratio of the Expenses (% of total expenses) in Ukraine in 2005 to that in 2008?
Make the answer very short. 0.98. What is the ratio of the Expenses (% of total expenses) in Israel in 2005 to that in 2009?
Your answer should be compact. 0.97. What is the ratio of the Expenses (% of total expenses) in Japan in 2005 to that in 2009?
Give a very brief answer. 1.15. What is the ratio of the Expenses (% of total expenses) of Macao in 2005 to that in 2009?
Provide a succinct answer. 1.72. What is the ratio of the Expenses (% of total expenses) in Ukraine in 2005 to that in 2009?
Give a very brief answer. 0.99. What is the ratio of the Expenses (% of total expenses) in Japan in 2005 to that in 2010?
Make the answer very short. 1.13. What is the ratio of the Expenses (% of total expenses) of Macao in 2005 to that in 2010?
Make the answer very short. 1.79. What is the ratio of the Expenses (% of total expenses) of Ukraine in 2005 to that in 2010?
Keep it short and to the point. 1.05. What is the ratio of the Expenses (% of total expenses) in Israel in 2005 to that in 2011?
Your response must be concise. 0.96. What is the ratio of the Expenses (% of total expenses) of Japan in 2005 to that in 2011?
Give a very brief answer. 1.17. What is the ratio of the Expenses (% of total expenses) of Macao in 2005 to that in 2011?
Give a very brief answer. 1.63. What is the ratio of the Expenses (% of total expenses) in Ukraine in 2005 to that in 2011?
Offer a very short reply. 1.1. What is the ratio of the Expenses (% of total expenses) in Israel in 2006 to that in 2007?
Your response must be concise. 0.99. What is the ratio of the Expenses (% of total expenses) of Japan in 2006 to that in 2007?
Your response must be concise. 0.96. What is the ratio of the Expenses (% of total expenses) in Ukraine in 2006 to that in 2007?
Offer a terse response. 0.96. What is the ratio of the Expenses (% of total expenses) in Israel in 2006 to that in 2008?
Offer a very short reply. 0.97. What is the ratio of the Expenses (% of total expenses) in Japan in 2006 to that in 2008?
Offer a terse response. 1.03. What is the ratio of the Expenses (% of total expenses) in Macao in 2006 to that in 2008?
Your response must be concise. 1.33. What is the ratio of the Expenses (% of total expenses) in Ukraine in 2006 to that in 2008?
Make the answer very short. 1. What is the ratio of the Expenses (% of total expenses) in Israel in 2006 to that in 2009?
Give a very brief answer. 0.97. What is the ratio of the Expenses (% of total expenses) of Japan in 2006 to that in 2009?
Keep it short and to the point. 1.17. What is the ratio of the Expenses (% of total expenses) of Macao in 2006 to that in 2009?
Offer a terse response. 1.59. What is the ratio of the Expenses (% of total expenses) in Ukraine in 2006 to that in 2009?
Provide a short and direct response. 1.01. What is the ratio of the Expenses (% of total expenses) of Israel in 2006 to that in 2010?
Your answer should be very brief. 0.96. What is the ratio of the Expenses (% of total expenses) in Japan in 2006 to that in 2010?
Keep it short and to the point. 1.15. What is the ratio of the Expenses (% of total expenses) of Macao in 2006 to that in 2010?
Make the answer very short. 1.65. What is the ratio of the Expenses (% of total expenses) of Ukraine in 2006 to that in 2010?
Your response must be concise. 1.07. What is the ratio of the Expenses (% of total expenses) in Israel in 2006 to that in 2011?
Provide a short and direct response. 0.96. What is the ratio of the Expenses (% of total expenses) in Japan in 2006 to that in 2011?
Provide a succinct answer. 1.19. What is the ratio of the Expenses (% of total expenses) in Macao in 2006 to that in 2011?
Offer a very short reply. 1.5. What is the ratio of the Expenses (% of total expenses) in Ukraine in 2006 to that in 2011?
Offer a very short reply. 1.12. What is the ratio of the Expenses (% of total expenses) in Israel in 2007 to that in 2008?
Make the answer very short. 0.98. What is the ratio of the Expenses (% of total expenses) of Japan in 2007 to that in 2008?
Your response must be concise. 1.07. What is the ratio of the Expenses (% of total expenses) in Macao in 2007 to that in 2008?
Keep it short and to the point. 1.34. What is the ratio of the Expenses (% of total expenses) of Ukraine in 2007 to that in 2008?
Provide a short and direct response. 1.05. What is the ratio of the Expenses (% of total expenses) of Japan in 2007 to that in 2009?
Give a very brief answer. 1.22. What is the ratio of the Expenses (% of total expenses) in Macao in 2007 to that in 2009?
Your answer should be very brief. 1.59. What is the ratio of the Expenses (% of total expenses) in Ukraine in 2007 to that in 2009?
Ensure brevity in your answer.  1.06. What is the ratio of the Expenses (% of total expenses) in Israel in 2007 to that in 2010?
Keep it short and to the point. 0.97. What is the ratio of the Expenses (% of total expenses) of Japan in 2007 to that in 2010?
Keep it short and to the point. 1.2. What is the ratio of the Expenses (% of total expenses) in Macao in 2007 to that in 2010?
Make the answer very short. 1.65. What is the ratio of the Expenses (% of total expenses) in Ukraine in 2007 to that in 2010?
Your response must be concise. 1.11. What is the ratio of the Expenses (% of total expenses) in Israel in 2007 to that in 2011?
Your answer should be compact. 0.97. What is the ratio of the Expenses (% of total expenses) of Japan in 2007 to that in 2011?
Offer a very short reply. 1.24. What is the ratio of the Expenses (% of total expenses) of Macao in 2007 to that in 2011?
Make the answer very short. 1.5. What is the ratio of the Expenses (% of total expenses) of Ukraine in 2007 to that in 2011?
Your response must be concise. 1.17. What is the ratio of the Expenses (% of total expenses) of Israel in 2008 to that in 2009?
Give a very brief answer. 1.01. What is the ratio of the Expenses (% of total expenses) in Japan in 2008 to that in 2009?
Ensure brevity in your answer.  1.14. What is the ratio of the Expenses (% of total expenses) in Macao in 2008 to that in 2009?
Provide a succinct answer. 1.19. What is the ratio of the Expenses (% of total expenses) of Ukraine in 2008 to that in 2009?
Provide a succinct answer. 1.01. What is the ratio of the Expenses (% of total expenses) in Israel in 2008 to that in 2010?
Your response must be concise. 0.99. What is the ratio of the Expenses (% of total expenses) of Japan in 2008 to that in 2010?
Offer a terse response. 1.12. What is the ratio of the Expenses (% of total expenses) in Macao in 2008 to that in 2010?
Your answer should be very brief. 1.23. What is the ratio of the Expenses (% of total expenses) of Ukraine in 2008 to that in 2010?
Your answer should be very brief. 1.06. What is the ratio of the Expenses (% of total expenses) in Israel in 2008 to that in 2011?
Offer a terse response. 0.99. What is the ratio of the Expenses (% of total expenses) in Japan in 2008 to that in 2011?
Ensure brevity in your answer.  1.16. What is the ratio of the Expenses (% of total expenses) in Macao in 2008 to that in 2011?
Keep it short and to the point. 1.12. What is the ratio of the Expenses (% of total expenses) in Ukraine in 2008 to that in 2011?
Provide a succinct answer. 1.12. What is the ratio of the Expenses (% of total expenses) in Israel in 2009 to that in 2010?
Your answer should be compact. 0.99. What is the ratio of the Expenses (% of total expenses) of Japan in 2009 to that in 2010?
Offer a very short reply. 0.98. What is the ratio of the Expenses (% of total expenses) of Macao in 2009 to that in 2010?
Provide a short and direct response. 1.04. What is the ratio of the Expenses (% of total expenses) of Ukraine in 2009 to that in 2010?
Provide a succinct answer. 1.05. What is the ratio of the Expenses (% of total expenses) of Israel in 2009 to that in 2011?
Provide a short and direct response. 0.98. What is the ratio of the Expenses (% of total expenses) of Japan in 2009 to that in 2011?
Ensure brevity in your answer.  1.02. What is the ratio of the Expenses (% of total expenses) of Macao in 2009 to that in 2011?
Offer a terse response. 0.95. What is the ratio of the Expenses (% of total expenses) of Ukraine in 2009 to that in 2011?
Make the answer very short. 1.11. What is the ratio of the Expenses (% of total expenses) in Japan in 2010 to that in 2011?
Your response must be concise. 1.04. What is the ratio of the Expenses (% of total expenses) of Macao in 2010 to that in 2011?
Offer a very short reply. 0.91. What is the ratio of the Expenses (% of total expenses) of Ukraine in 2010 to that in 2011?
Make the answer very short. 1.05. What is the difference between the highest and the second highest Expenses (% of total expenses) of Israel?
Make the answer very short. 0.08. What is the difference between the highest and the second highest Expenses (% of total expenses) in Japan?
Your answer should be compact. 0.36. What is the difference between the highest and the second highest Expenses (% of total expenses) in Macao?
Your response must be concise. 3.78. What is the difference between the highest and the second highest Expenses (% of total expenses) in Ukraine?
Make the answer very short. 0.56. What is the difference between the highest and the lowest Expenses (% of total expenses) in Israel?
Keep it short and to the point. 1.05. What is the difference between the highest and the lowest Expenses (% of total expenses) in Japan?
Your answer should be compact. 1.6. What is the difference between the highest and the lowest Expenses (% of total expenses) of Macao?
Make the answer very short. 21.7. What is the difference between the highest and the lowest Expenses (% of total expenses) in Ukraine?
Your answer should be compact. 2.01. 